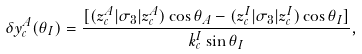Convert formula to latex. <formula><loc_0><loc_0><loc_500><loc_500>\delta y ^ { A } _ { c } ( \theta _ { I } ) = \frac { [ ( z _ { c } ^ { A } | \sigma _ { 3 } | z _ { c } ^ { A } ) \cos \theta _ { A } - ( z _ { c } ^ { I } | \sigma _ { 3 } | z _ { c } ^ { I } ) \cos \theta _ { I } ] } { k _ { c } ^ { I } \sin \theta _ { I } } ,</formula> 